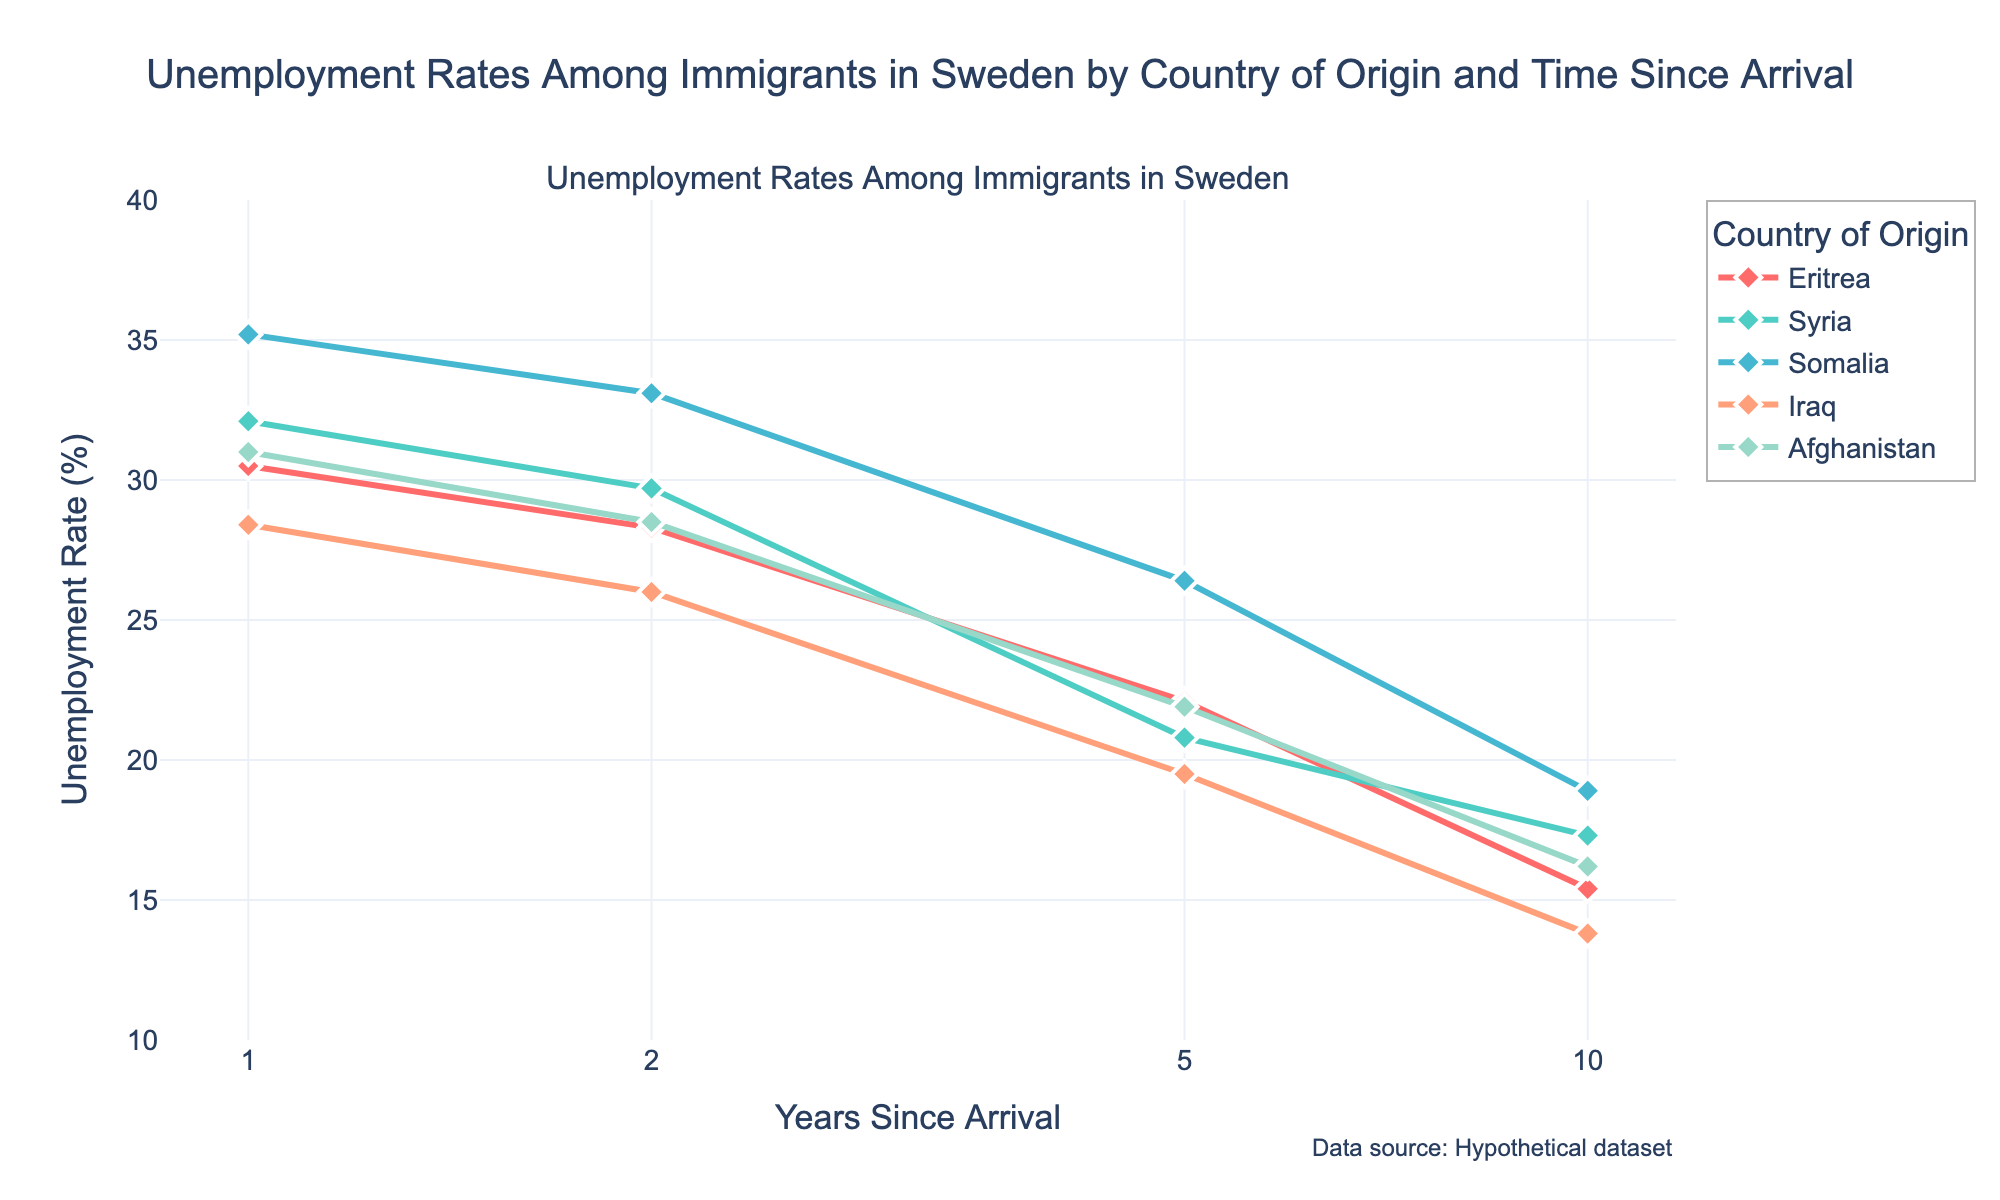What is the title of the subplot? The title of the subplot is placed at the top center and is provided in the code as "Unemployment Rates Among Immigrants in Sweden by Country of Origin and Time Since Arrival".
Answer: Unemployment Rates Among Immigrants in Sweden by Country of Origin and Time Since Arrival How many unique countries of origin are displayed in the figure? The number of unique countries of origin can be determined by counting the distinct lines in the plot, each representing a different country. The given data lists Eritrea, Syria, Somalia, Iraq, and Afghanistan.
Answer: Five What is the unemployment rate for Eritrean immigrants who have been in Sweden for 5 years? Look at the point corresponding to 5 years since arrival for Eritrea and read the corresponding unemployment rate from the y-axis. For Eritrea at 5 years, the unemployment rate is marked as 22.1%.
Answer: 22.1% Which country has the highest unemployment rate for the first year since arrival? Compare the y-values for each country at the x-value of 1 year since arrival. The highest y-value at this point corresponds to Somalia, with a rate of 35.2%.
Answer: Somalia How does the unemployment rate change for Syrian immigrants from 1 year to 10 years since arrival? Find the unemployment rates at 1 year (32.1%) and at 10 years (17.3%) for Syria. Calculate the difference: 32.1% - 17.3% = 14.8%. Syrian unemployment rates decrease by 14.8% over this period.
Answer: Decreases by 14.8% Which country exhibits the largest decrease in unemployment rate from the 2nd year to the 10th year? Calculate the decrease for each country between 2 and 10 years:
- Eritrea: 28.3 - 15.4 = 12.9
- Syria: 29.7 - 17.3 = 12.4
- Somalia: 33.1 - 18.9 = 14.2
- Iraq: 26.0 - 13.8 = 12.2
- Afghanistan: 28.5 - 16.2 = 12.3
Somalia has the largest decrease of 14.2%.
Answer: Somalia For Afghan immigrants, what is the general trend in unemployment rates as time since arrival increases? Analyze the data points for Afghanistan: 31.0% at 1 year, 28.5% at 2 years, 21.9% at 5 years, and 16.2% at 10 years. The trend shows a consistent decrease in the unemployment rate as time since arrival increases.
Answer: Decreasing At which years does the plot use specific tick values on the x-axis, and why might these specific values be chosen? The x-axis uses the log-scale with tick values at 1, 2, 5, and 10 years. These values are chosen to evenly distribute major milestones on a logarithmic scale, showing more detail at shorter time spans while covering a wide range.
Answer: 1, 2, 5, and 10 years Which country shows the smallest change in unemployment rate from 2 years to 5 years since arrival? Calculate the change for each country between 2 and 5 years:
- Eritrea: 28.3 - 22.1 = 6.2
- Syria: 29.7 - 20.8 = 8.9
- Somalia: 33.1 - 26.4 = 6.7
- Iraq: 26.0 - 19.5 = 6.5
- Afghanistan: 28.5 - 21.9 = 6.6
The smallest change is for Eritrea with a 6.2% decrease.
Answer: Eritrea 